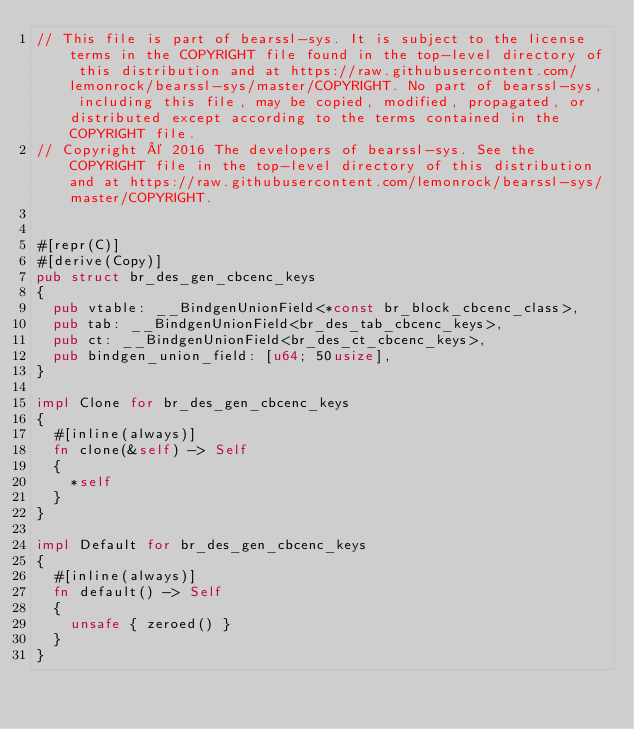Convert code to text. <code><loc_0><loc_0><loc_500><loc_500><_Rust_>// This file is part of bearssl-sys. It is subject to the license terms in the COPYRIGHT file found in the top-level directory of this distribution and at https://raw.githubusercontent.com/lemonrock/bearssl-sys/master/COPYRIGHT. No part of bearssl-sys, including this file, may be copied, modified, propagated, or distributed except according to the terms contained in the COPYRIGHT file.
// Copyright © 2016 The developers of bearssl-sys. See the COPYRIGHT file in the top-level directory of this distribution and at https://raw.githubusercontent.com/lemonrock/bearssl-sys/master/COPYRIGHT.


#[repr(C)]
#[derive(Copy)]
pub struct br_des_gen_cbcenc_keys
{
	pub vtable: __BindgenUnionField<*const br_block_cbcenc_class>,
	pub tab: __BindgenUnionField<br_des_tab_cbcenc_keys>,
	pub ct: __BindgenUnionField<br_des_ct_cbcenc_keys>,
	pub bindgen_union_field: [u64; 50usize],
}

impl Clone for br_des_gen_cbcenc_keys
{
	#[inline(always)]
	fn clone(&self) -> Self
	{
		*self
	}
}

impl Default for br_des_gen_cbcenc_keys
{
	#[inline(always)]
	fn default() -> Self
	{
		unsafe { zeroed() }
	}
}
</code> 